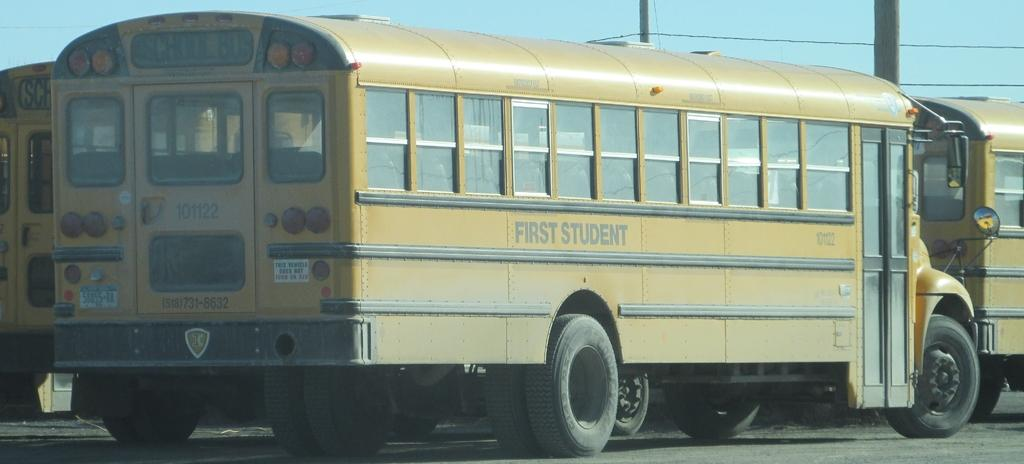What type of vehicles are parked on the road in the image? There are school buses parked on the road in the image. What can be seen in the background of the image? There are poles with wires in the background. What is visible at the top of the image? The sky is visible at the top of the image. How much money is being exchanged between the spies in the image? There are no spies or money present in the image; it features school buses parked on the road with poles and wires in the background. 